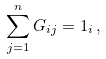<formula> <loc_0><loc_0><loc_500><loc_500>\sum _ { j = 1 } ^ { n } G _ { i j } = 1 _ { i } \, ,</formula> 